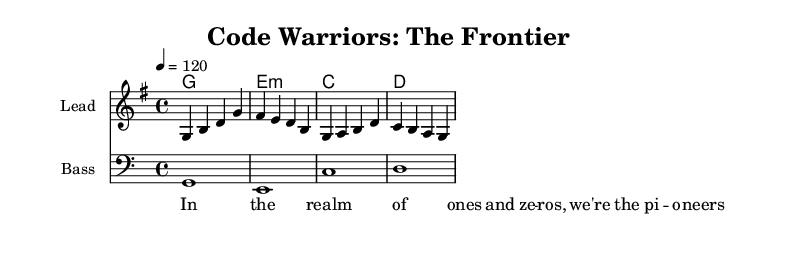What is the key signature of this music? The key signature is indicated at the beginning of the piece with one sharp, which corresponds to the key of G major.
Answer: G major What is the time signature of this music? The time signature is represented in the initial section of the sheet music and shows that there are four beats in each measure.
Answer: Four four What is the tempo marking of this music? The tempo marking is provided in the score as "4 = 120," indicating that there are 120 beats per minute.
Answer: 120 What are the main instrumental parts listed in the sheet music? The sheet music specifically identifies three distinct instrumental parts: "Lead," "Bass," and "ChordNames." Together, they provide a full texture for the song.
Answer: Lead, Bass, ChordNames What are the first three chords in the harmonies? The first three chords, presented in the chord section, are G major, E minor, and C major. They represent the fundamental harmonic structure of the piece.
Answer: G, E minor, C How many measures are in the melody section? By counting the number of separated sections within the melody staff, there are four measures listed in total.
Answer: Four What phrase from the lyrics suggests a pioneering theme? The phrase "we're the pioneers" within the lyrics explicitly emphasizes the theme of exploration and innovation, resonating with the pioneering spirit of game developers.
Answer: we're the pioneers 